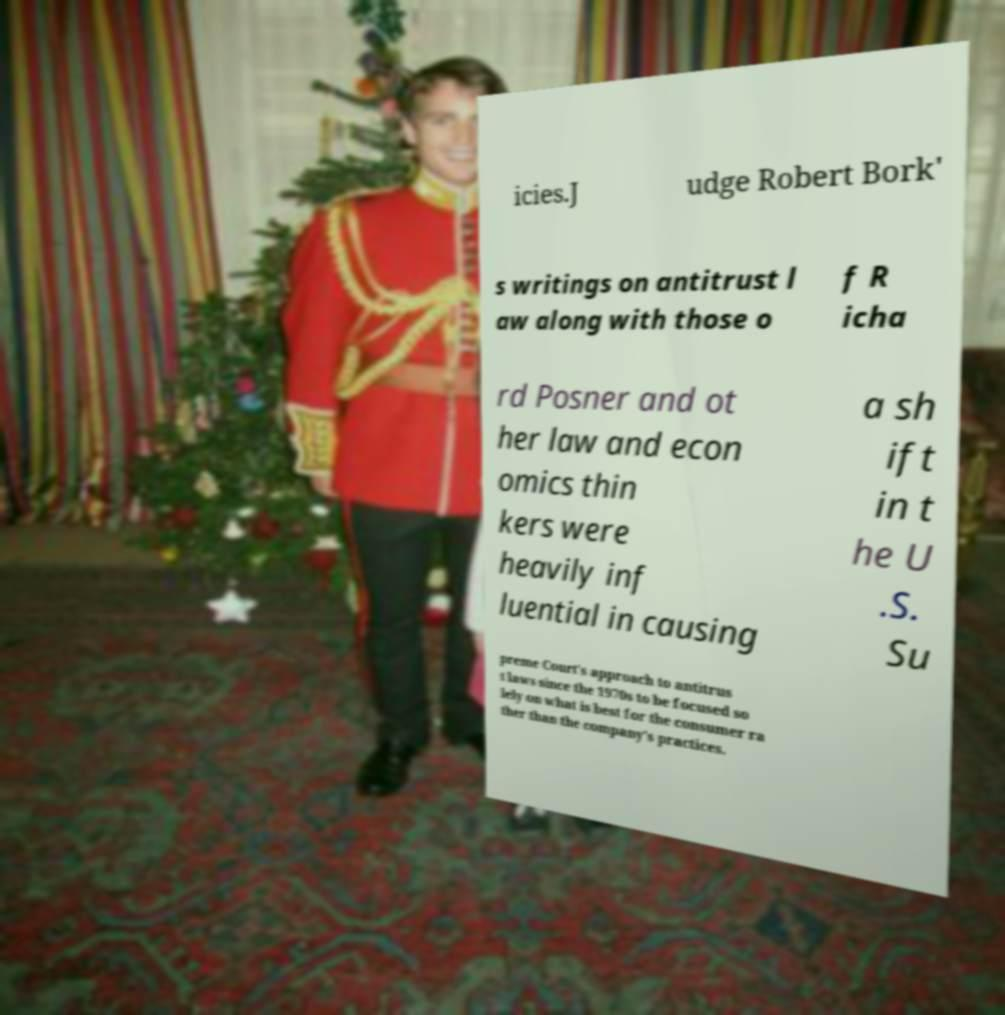I need the written content from this picture converted into text. Can you do that? icies.J udge Robert Bork' s writings on antitrust l aw along with those o f R icha rd Posner and ot her law and econ omics thin kers were heavily inf luential in causing a sh ift in t he U .S. Su preme Court's approach to antitrus t laws since the 1970s to be focused so lely on what is best for the consumer ra ther than the company's practices. 